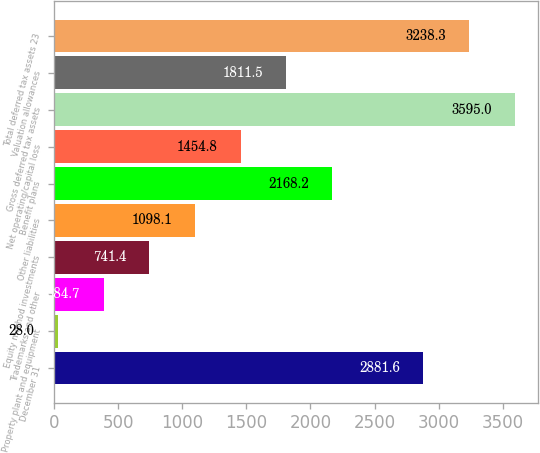Convert chart. <chart><loc_0><loc_0><loc_500><loc_500><bar_chart><fcel>December 31<fcel>Property plant and equipment<fcel>Trademarks and other<fcel>Equity method investments<fcel>Other liabilities<fcel>Benefit plans<fcel>Net operating/capital loss<fcel>Gross deferred tax assets<fcel>Valuation allowances<fcel>Total deferred tax assets 23<nl><fcel>2881.6<fcel>28<fcel>384.7<fcel>741.4<fcel>1098.1<fcel>2168.2<fcel>1454.8<fcel>3595<fcel>1811.5<fcel>3238.3<nl></chart> 